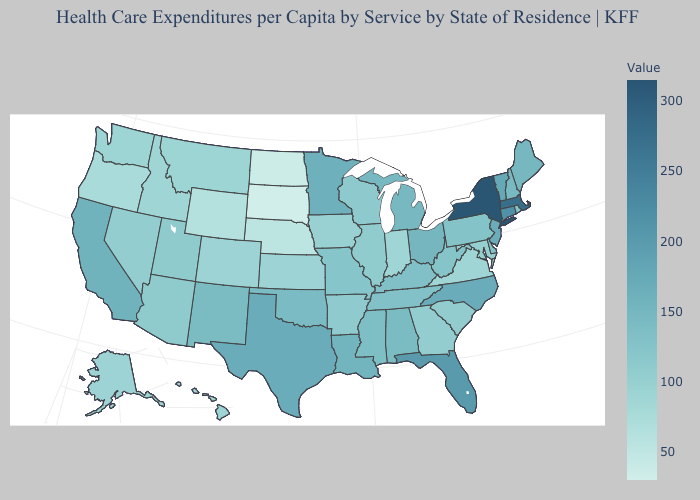Does Alaska have a higher value than Wyoming?
Keep it brief. Yes. Does New Mexico have the lowest value in the USA?
Write a very short answer. No. Which states have the lowest value in the Northeast?
Quick response, please. Rhode Island. Which states have the lowest value in the USA?
Give a very brief answer. South Dakota. Which states hav the highest value in the Northeast?
Concise answer only. New York. Does Wisconsin have the lowest value in the USA?
Short answer required. No. 